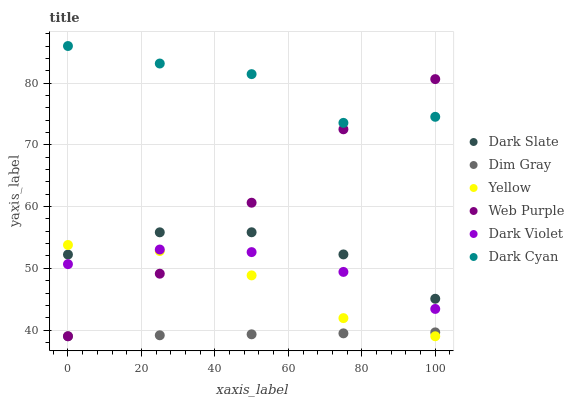Does Dim Gray have the minimum area under the curve?
Answer yes or no. Yes. Does Dark Cyan have the maximum area under the curve?
Answer yes or no. Yes. Does Dark Violet have the minimum area under the curve?
Answer yes or no. No. Does Dark Violet have the maximum area under the curve?
Answer yes or no. No. Is Dim Gray the smoothest?
Answer yes or no. Yes. Is Dark Cyan the roughest?
Answer yes or no. Yes. Is Dark Violet the smoothest?
Answer yes or no. No. Is Dark Violet the roughest?
Answer yes or no. No. Does Dim Gray have the lowest value?
Answer yes or no. Yes. Does Dark Violet have the lowest value?
Answer yes or no. No. Does Dark Cyan have the highest value?
Answer yes or no. Yes. Does Dark Violet have the highest value?
Answer yes or no. No. Is Dark Violet less than Dark Slate?
Answer yes or no. Yes. Is Dark Cyan greater than Dark Slate?
Answer yes or no. Yes. Does Web Purple intersect Dim Gray?
Answer yes or no. Yes. Is Web Purple less than Dim Gray?
Answer yes or no. No. Is Web Purple greater than Dim Gray?
Answer yes or no. No. Does Dark Violet intersect Dark Slate?
Answer yes or no. No. 